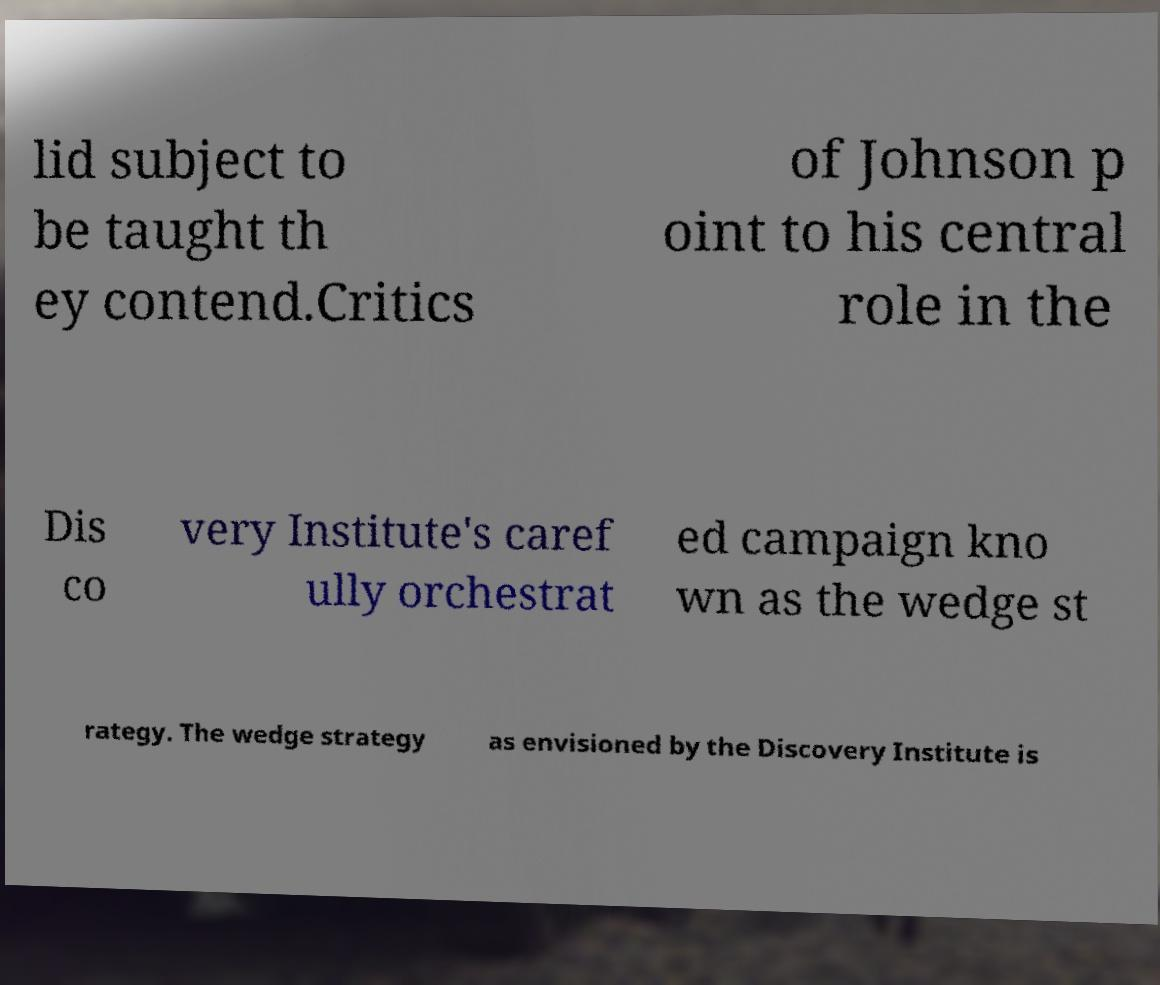Can you read and provide the text displayed in the image?This photo seems to have some interesting text. Can you extract and type it out for me? lid subject to be taught th ey contend.Critics of Johnson p oint to his central role in the Dis co very Institute's caref ully orchestrat ed campaign kno wn as the wedge st rategy. The wedge strategy as envisioned by the Discovery Institute is 